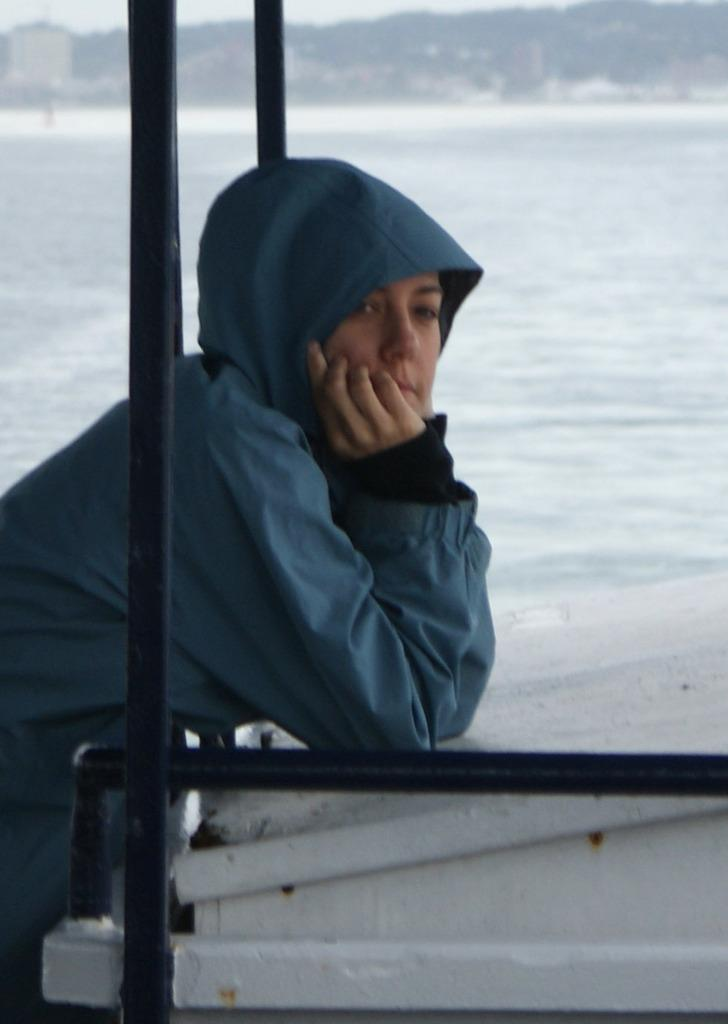What is the person in the image doing? The person is standing at the wall in the image. What can be seen in the background of the image? Water, a hill, and the sky are visible in the background of the image. What type of snake is crawling on the person's shoulder in the image? There is no snake present in the image; the person is standing at the wall without any visible animals. 